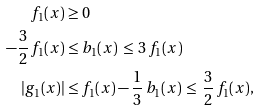Convert formula to latex. <formula><loc_0><loc_0><loc_500><loc_500>f _ { 1 } ( x ) & \geq 0 \\ - \frac { 3 } { 2 } \, f _ { 1 } ( x ) & \leq b _ { 1 } ( x ) \, \leq \, 3 \, f _ { 1 } ( x ) \\ | g _ { 1 } ( x ) | & \leq f _ { 1 } ( x ) - \frac { 1 } { 3 } \, b _ { 1 } ( x ) \, \leq \, \frac { 3 } { 2 } \, f _ { 1 } ( x ) ,</formula> 